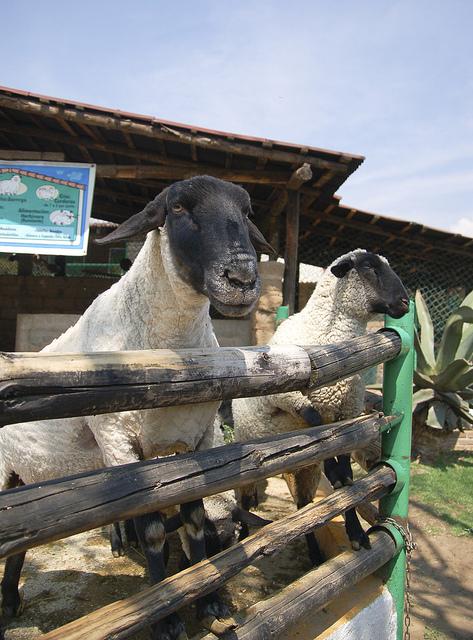How many sheep are standing up against the fence?
Concise answer only. 2. What material is the fence made of?
Be succinct. Wood. What color are the sheeps' heads?
Give a very brief answer. Black. 